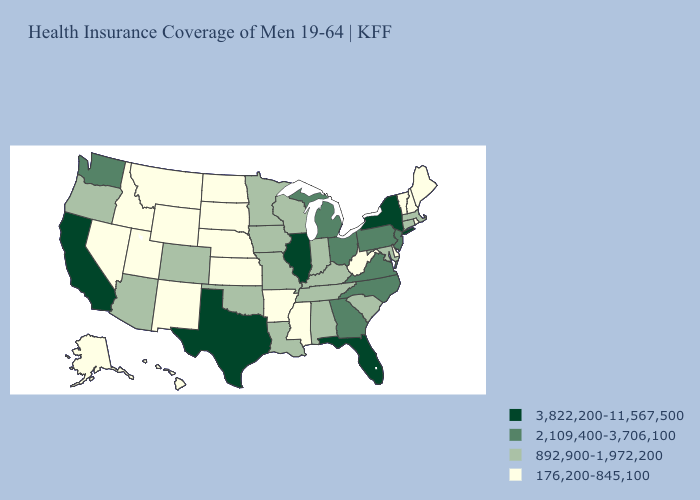Name the states that have a value in the range 3,822,200-11,567,500?
Answer briefly. California, Florida, Illinois, New York, Texas. What is the lowest value in the Northeast?
Quick response, please. 176,200-845,100. Name the states that have a value in the range 3,822,200-11,567,500?
Keep it brief. California, Florida, Illinois, New York, Texas. Which states have the lowest value in the USA?
Concise answer only. Alaska, Arkansas, Delaware, Hawaii, Idaho, Kansas, Maine, Mississippi, Montana, Nebraska, Nevada, New Hampshire, New Mexico, North Dakota, Rhode Island, South Dakota, Utah, Vermont, West Virginia, Wyoming. Name the states that have a value in the range 176,200-845,100?
Write a very short answer. Alaska, Arkansas, Delaware, Hawaii, Idaho, Kansas, Maine, Mississippi, Montana, Nebraska, Nevada, New Hampshire, New Mexico, North Dakota, Rhode Island, South Dakota, Utah, Vermont, West Virginia, Wyoming. What is the lowest value in the Northeast?
Concise answer only. 176,200-845,100. Does New Hampshire have the lowest value in the USA?
Concise answer only. Yes. Does the map have missing data?
Write a very short answer. No. What is the value of New Mexico?
Short answer required. 176,200-845,100. Among the states that border New Jersey , which have the lowest value?
Keep it brief. Delaware. Name the states that have a value in the range 2,109,400-3,706,100?
Give a very brief answer. Georgia, Michigan, New Jersey, North Carolina, Ohio, Pennsylvania, Virginia, Washington. Does Maryland have the lowest value in the USA?
Concise answer only. No. Which states hav the highest value in the West?
Answer briefly. California. Name the states that have a value in the range 892,900-1,972,200?
Write a very short answer. Alabama, Arizona, Colorado, Connecticut, Indiana, Iowa, Kentucky, Louisiana, Maryland, Massachusetts, Minnesota, Missouri, Oklahoma, Oregon, South Carolina, Tennessee, Wisconsin. Which states hav the highest value in the West?
Concise answer only. California. 